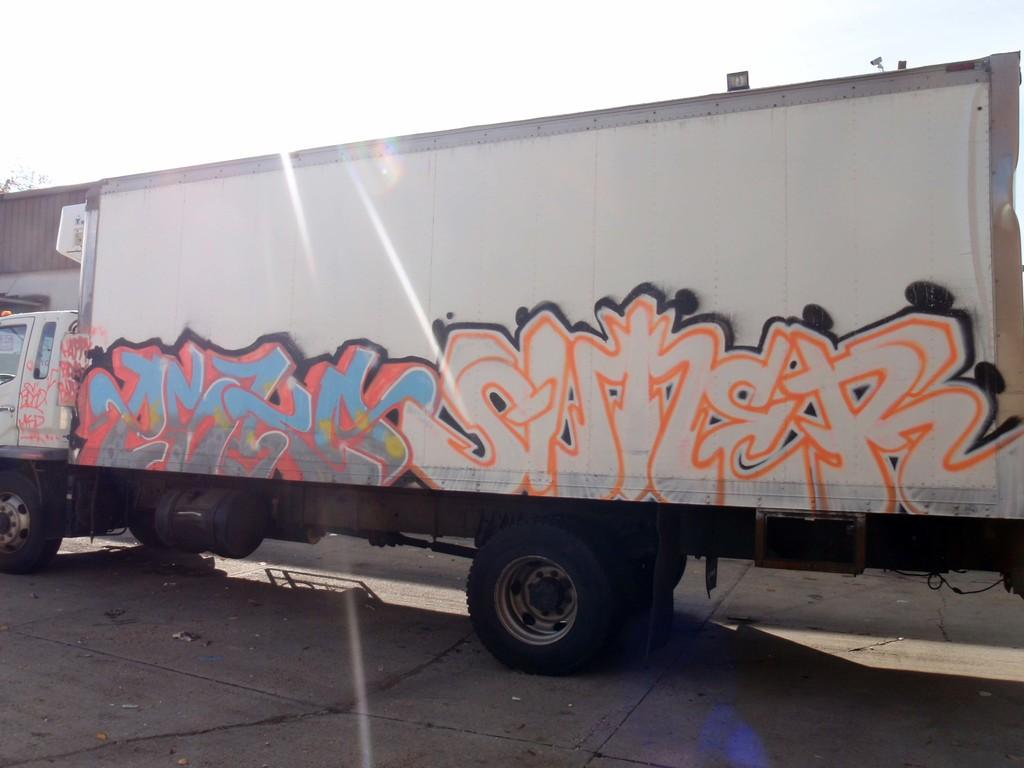What is the main subject in the image? There is a vehicle in the image. What can be seen in the background of the image? The sky is visible in the background of the image. What type of substance is being cut with a knife in the image? There is no knife or substance present in the image; it only features a vehicle and the sky in the background. 